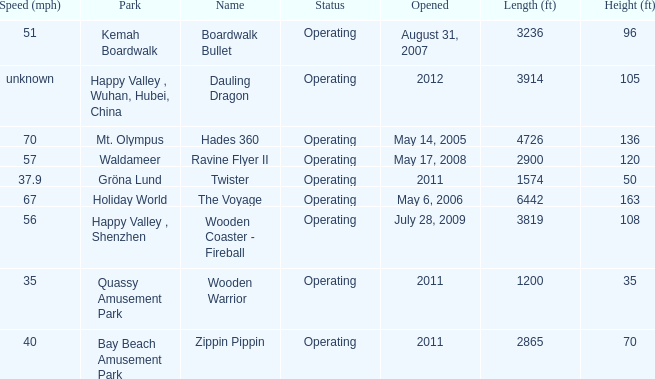What park is Boardwalk Bullet located in? Kemah Boardwalk. 